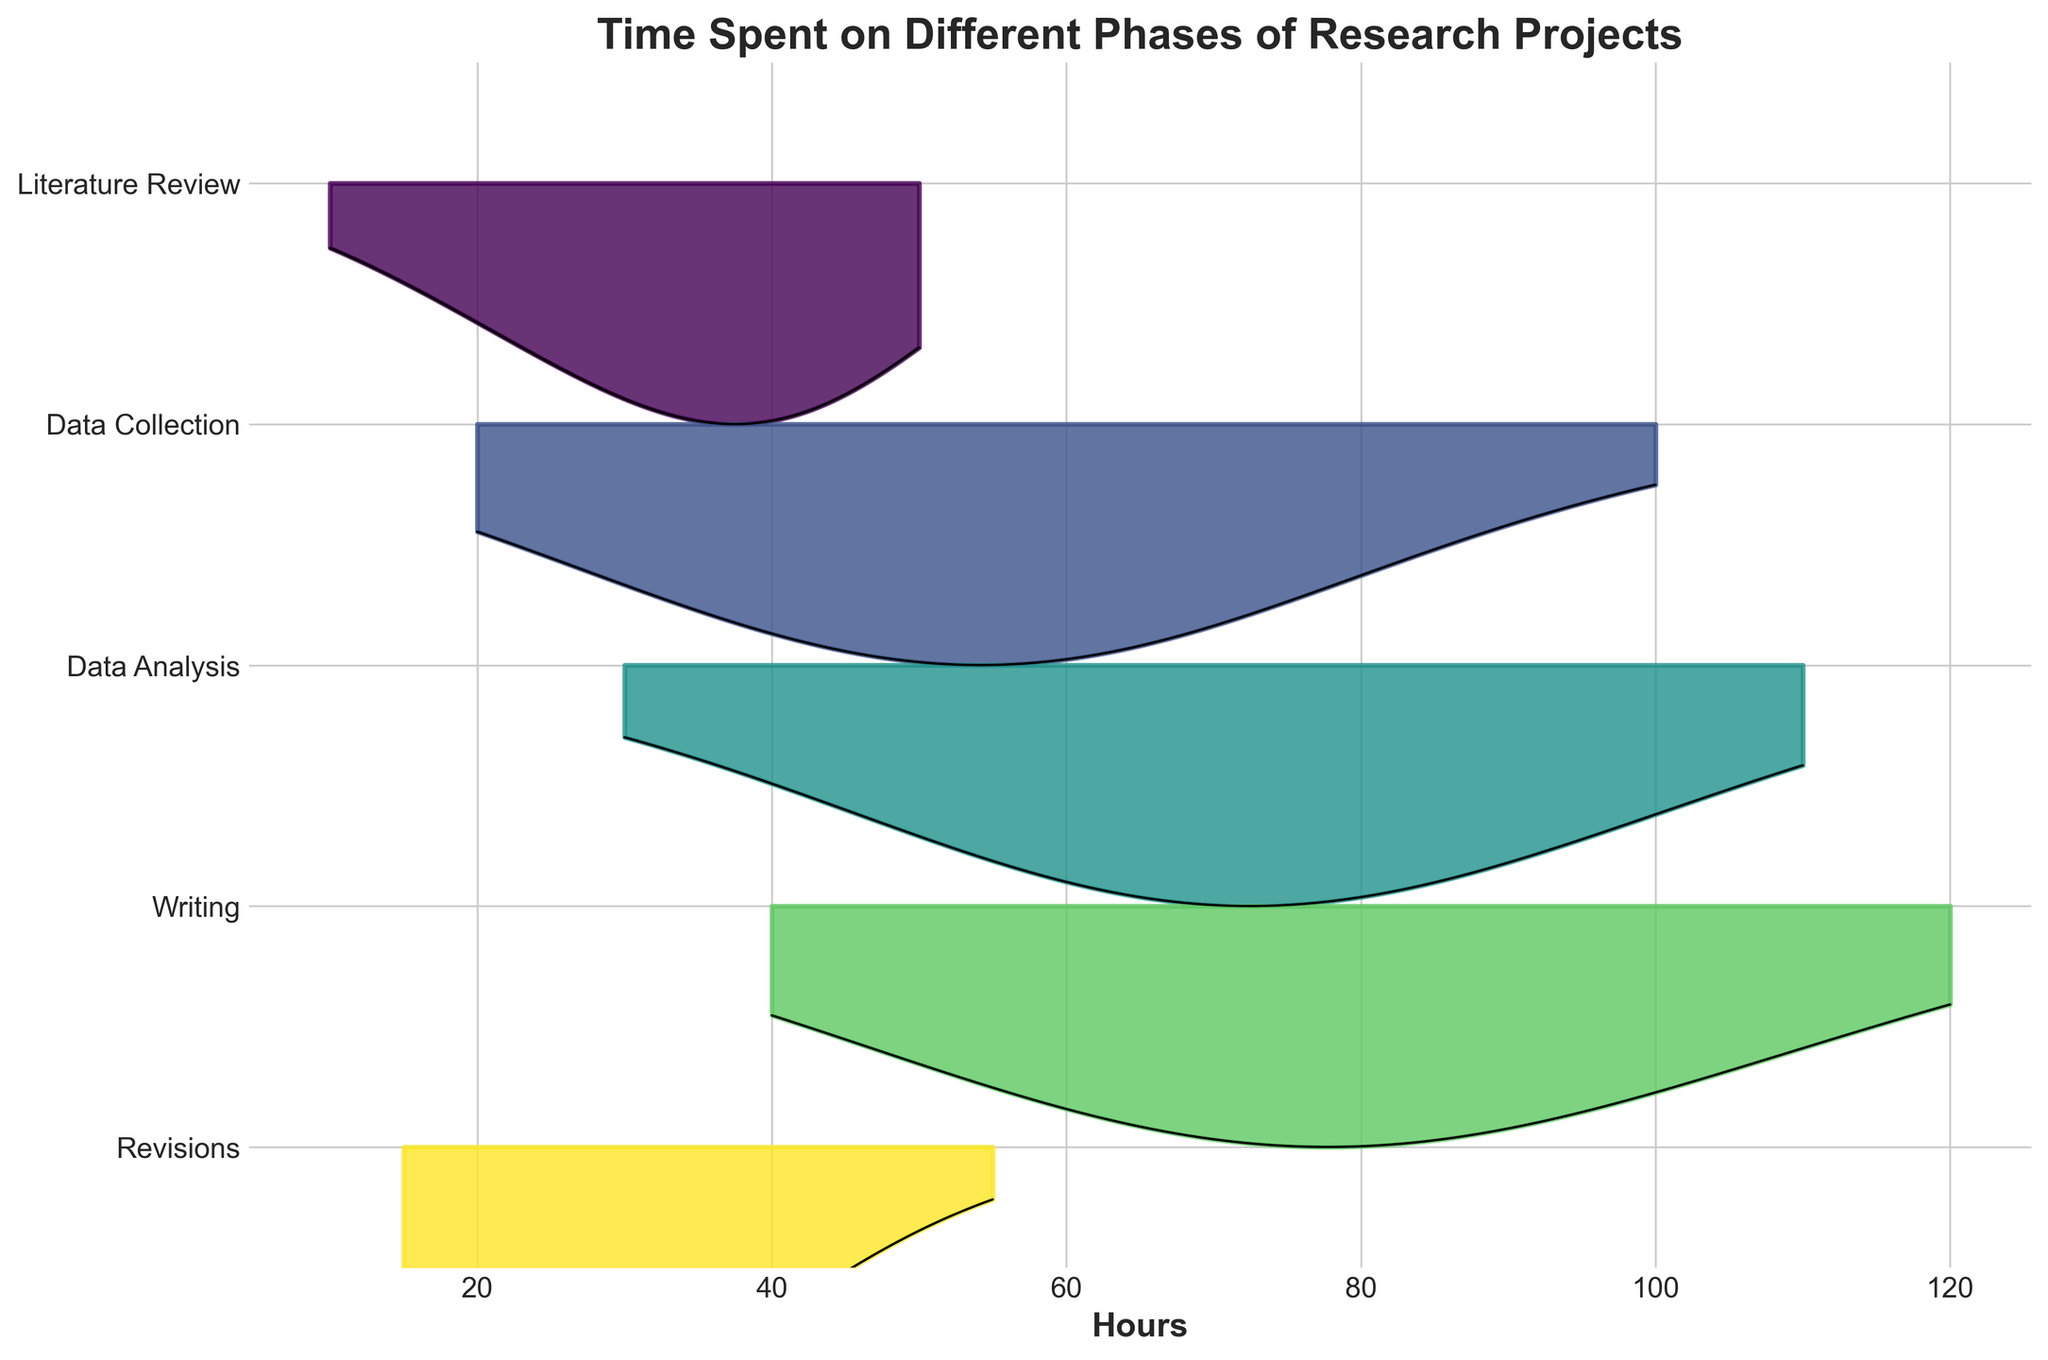What is the title of the figure? The title is displayed at the top of the figure in bold text and is meant to describe the content of the figure.
Answer: Time Spent on Different Phases of Research Projects Which phase is placed at the bottom of the plot? The y-axis labels represent the different phases, and the phase listed at the bottom in the inverted y-axis is the last one.
Answer: Literature Review Which phase has the highest peak frequency for the longest hours spent? Look at the peaks of the ridgelines and identify which phase has the highest peak furthest to the right side of the x-axis.
Answer: Writing Which two phases have the most similar distribution in time spent, based on the ridgeline plot? Compare the shapes and peaks of the ridgelines to see which ones look most similar in terms of time spent distribution.
Answer: Data Analysis and Writing What is the approximate duration for the peak frequency in the Data Collection phase? Identify the highest peak in the Data Collection ridgeline and note the corresponding x-axis value for hours.
Answer: 60 hours How many phases have their peak frequency within the first 40 hours? Count the phases with ridgelines peaking at or before the 40-hour mark on the x-axis.
Answer: Three Based on the plot, which phase shows the most spread-out time distribution? Look for the ridgeline that covers the widest range on the x-axis, indicating a more spread distribution of time spent.
Answer: Data Collection Comparing the Data Analysis and Data Collection phases, which one has a higher frequency at 50 hours? Observe the frequency level at 50 hours for both ridgelines to determine which has a higher peak at that point.
Answer: Data Analysis 